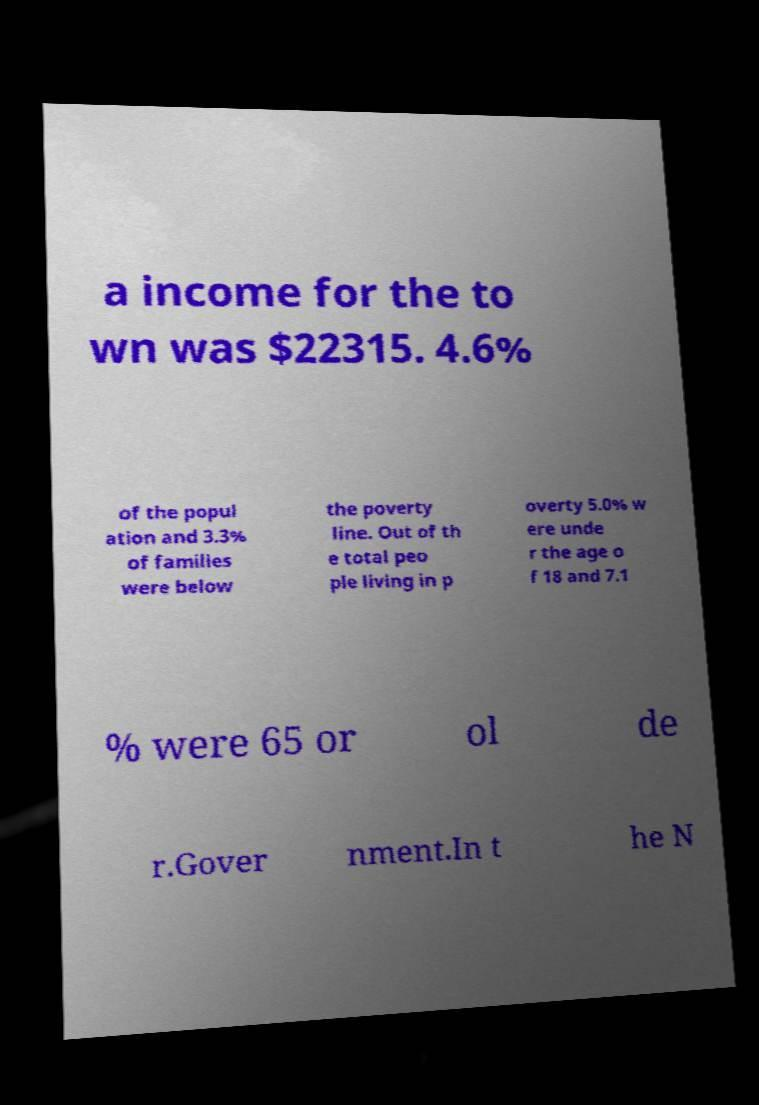Could you assist in decoding the text presented in this image and type it out clearly? a income for the to wn was $22315. 4.6% of the popul ation and 3.3% of families were below the poverty line. Out of th e total peo ple living in p overty 5.0% w ere unde r the age o f 18 and 7.1 % were 65 or ol de r.Gover nment.In t he N 